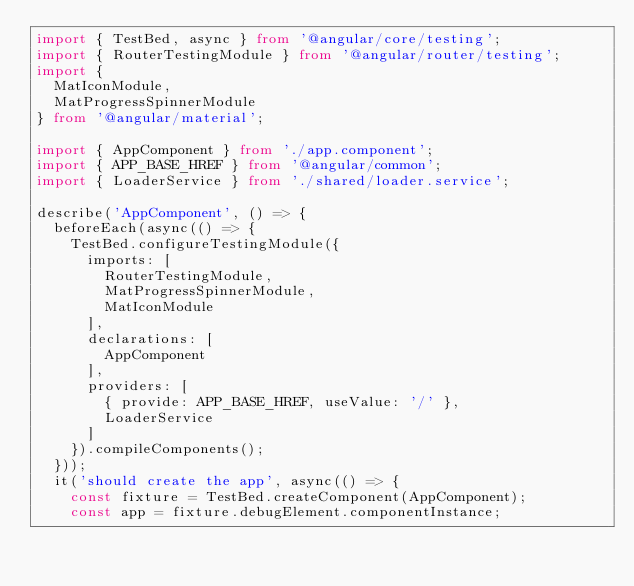<code> <loc_0><loc_0><loc_500><loc_500><_TypeScript_>import { TestBed, async } from '@angular/core/testing';
import { RouterTestingModule } from '@angular/router/testing';
import {
  MatIconModule,
  MatProgressSpinnerModule
} from '@angular/material';

import { AppComponent } from './app.component';
import { APP_BASE_HREF } from '@angular/common';
import { LoaderService } from './shared/loader.service';

describe('AppComponent', () => {
  beforeEach(async(() => {
    TestBed.configureTestingModule({
      imports: [
        RouterTestingModule,
        MatProgressSpinnerModule,
        MatIconModule
      ],
      declarations: [
        AppComponent
      ],
      providers: [
        { provide: APP_BASE_HREF, useValue: '/' },
        LoaderService
      ]
    }).compileComponents();
  }));
  it('should create the app', async(() => {
    const fixture = TestBed.createComponent(AppComponent);
    const app = fixture.debugElement.componentInstance;</code> 